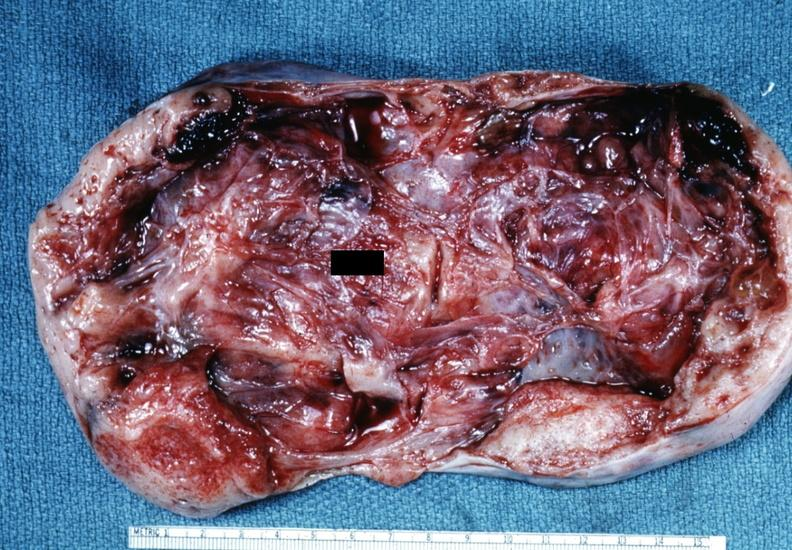how is this partially fixed gross not?
Answer the question using a single word or phrase. Diagnostic 